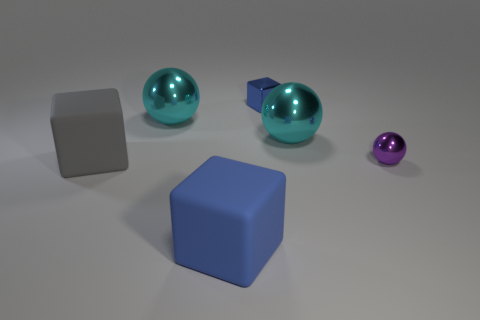What might the relative sizes of these objects suggest about their use? The relative sizes of the objects suggest a variety of potential uses. The larger cyan spheres might be decorative or part of a larger installation, while the small purple sphere could be a small ball used for leisure activities. The cubes could serve as weights or stands, given their sturdy shapes and flat surfaces. 